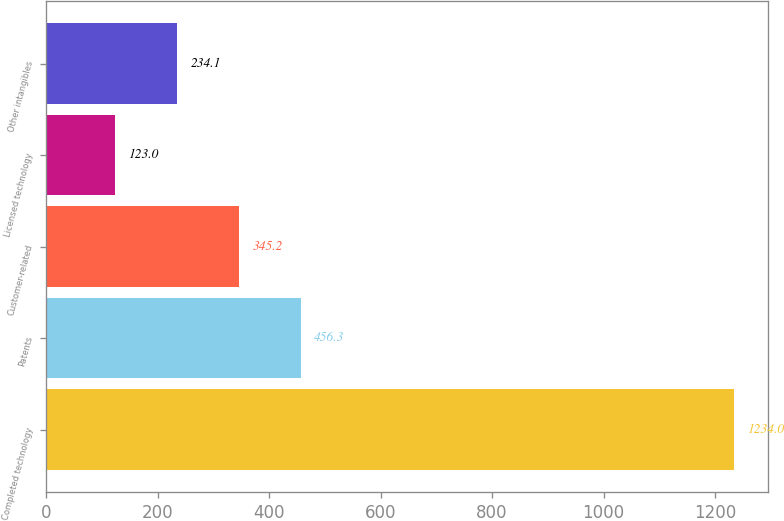Convert chart to OTSL. <chart><loc_0><loc_0><loc_500><loc_500><bar_chart><fcel>Completed technology<fcel>Patents<fcel>Customer-related<fcel>Licensed technology<fcel>Other intangibles<nl><fcel>1234<fcel>456.3<fcel>345.2<fcel>123<fcel>234.1<nl></chart> 